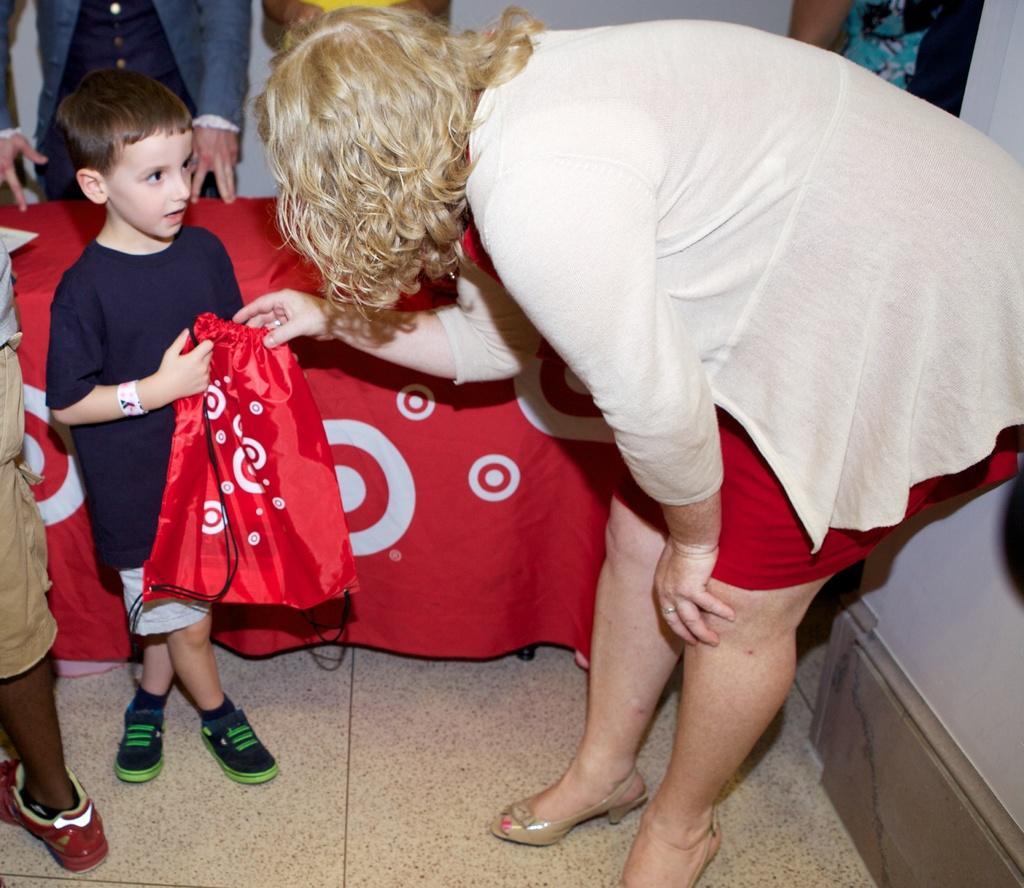In one or two sentences, can you explain what this image depicts? This image consists of some persons. There is a table in the middle. On that there is a red color cloth. There are women and kid in the middle. The kid is holding a red color bag. 